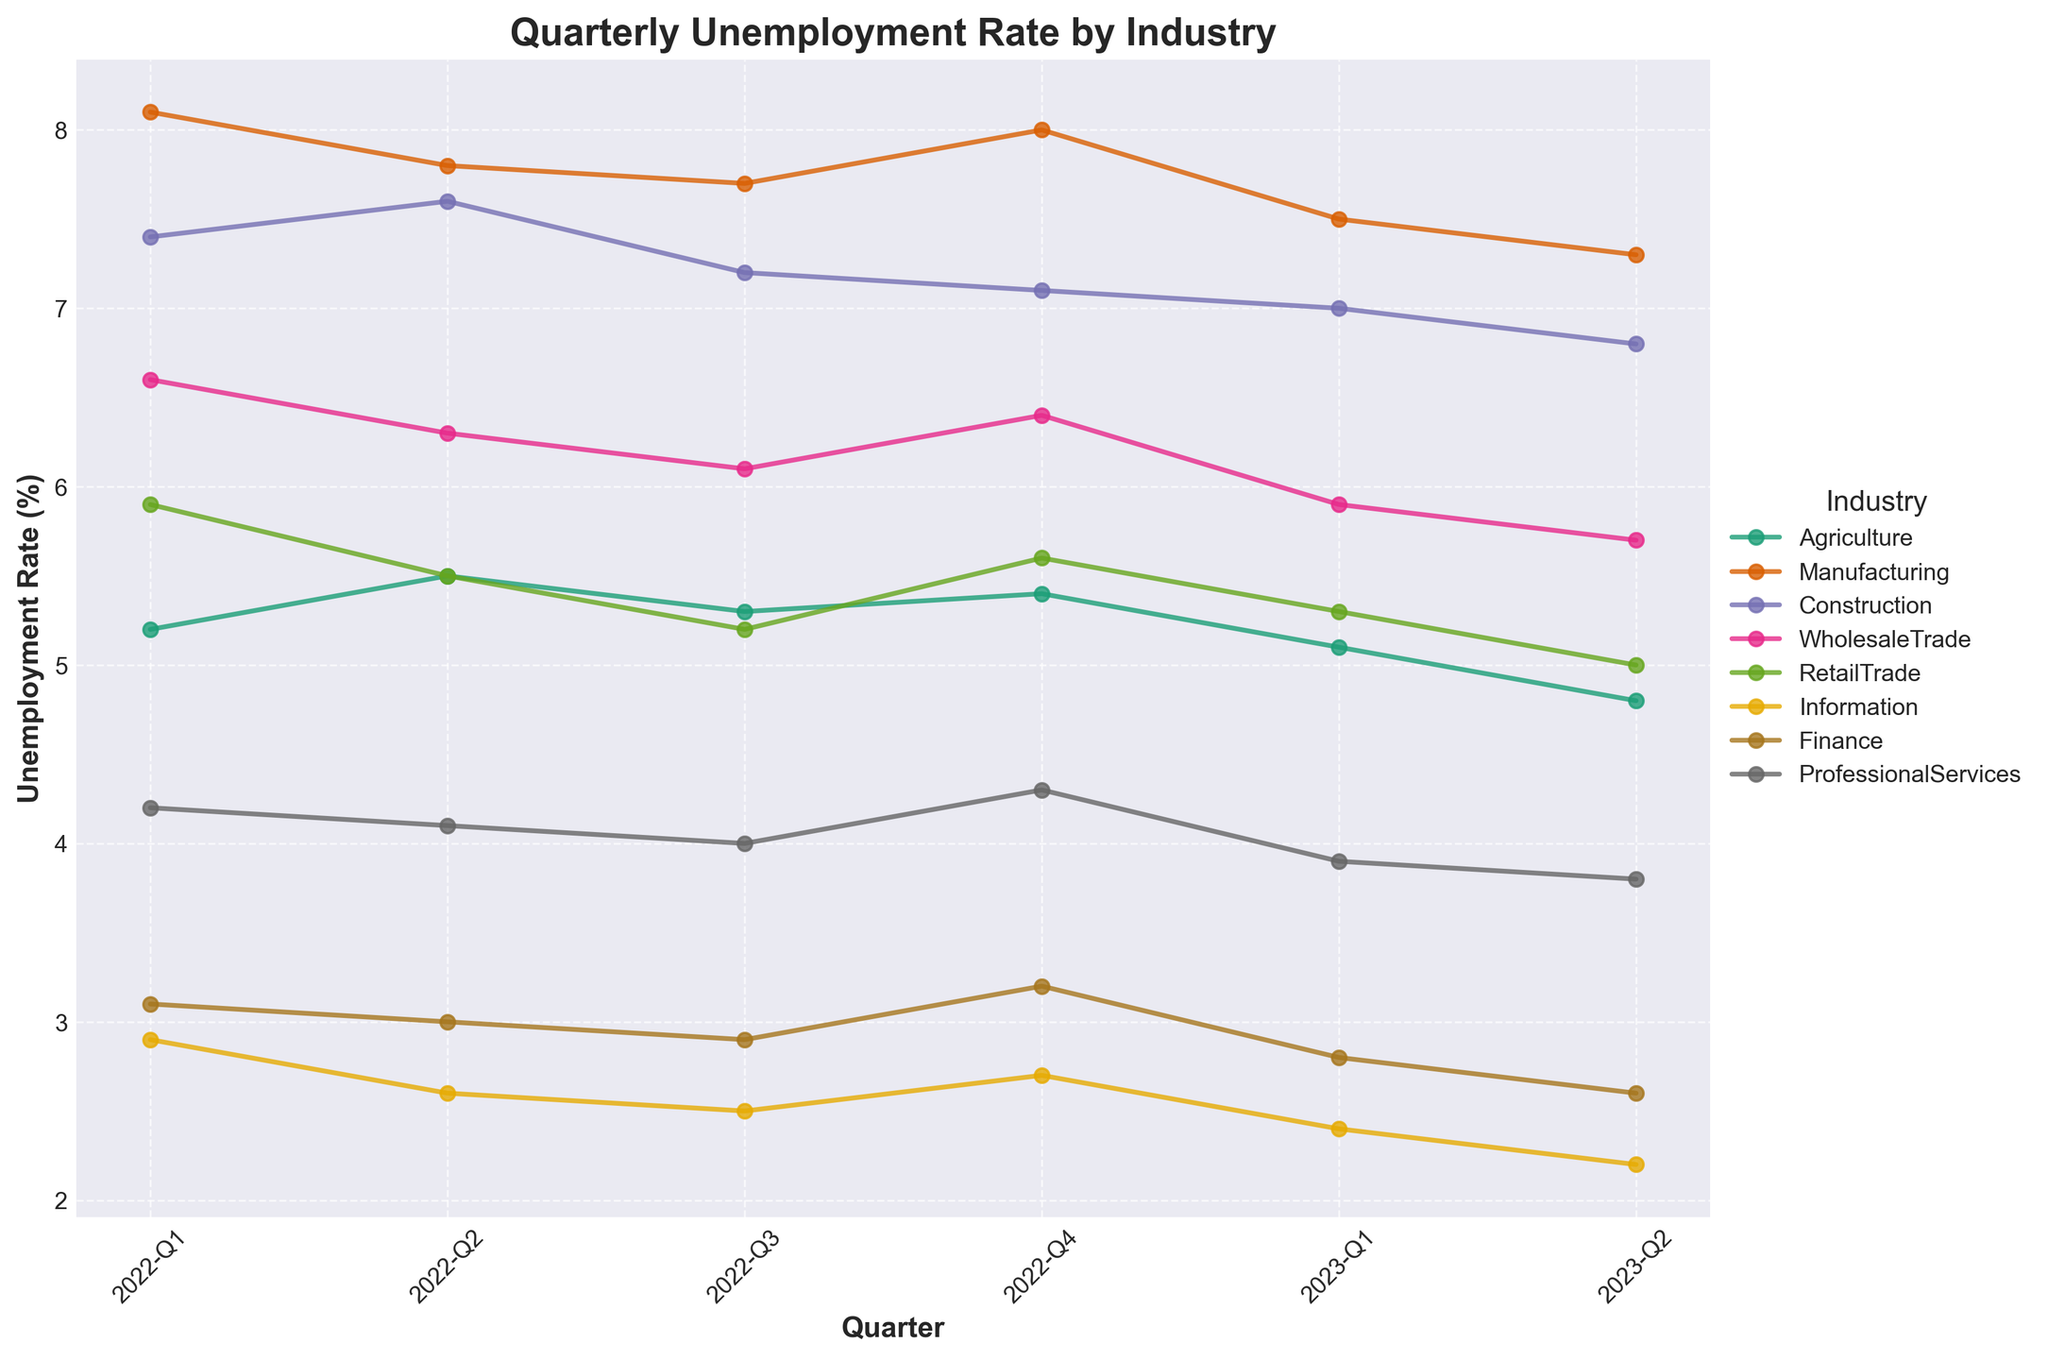What's the title of the figure? The title is displayed at the top center of the figure. It succinctly describes the content of the plot, highlighting that it's about quarterly unemployment rates across different industries.
Answer: Quarterly Unemployment Rate by Industry Which industry had the highest unemployment rate in 2022-Q4? Look at the 2022-Q4 points on the curve and identify which industry has the highest unemployment rate.
Answer: Manufacturing What is the trend of the unemployment rate in the Information industry from 2022-Q1 to 2023-Q2? Trace the curve for the Information industry from 2022-Q1 to 2023-Q2, noting the changes in the unemployment rate over each subsequent quarter. The trend shows a continuous decline.
Answer: Decreasing What is the average unemployment rate in the Retail Trade industry across all quarters displayed? Find the unemployment rates for the Retail Trade industry for each quarter, sum them up and then divide by the number of quarters (6).
Answer: (5.9 + 5.5 + 5.2 + 5.6 + 5.3 + 5.0) / 6 = 5.42% Between which two quarters did the Agriculture industry see the largest increase in unemployment rate? Compare the changes in the unemployment rate for the Agriculture industry between each pair of consecutive quarters. Identify which pair has the largest positive difference.
Answer: 2022-Q1 to 2022-Q2 Is there any industry that never reached an unemployment rate above 4% in the given time period? Check each industry’s curve to see if there are any points above 4%. The Information industry stays below 4% throughout the period.
Answer: Information Which industry experienced the most fluctuations in unemployment rate over the given quarters? Compare the ranges (maximum - minimum) of unemployment rates for each industry across the quarters. The industry with the largest range had the most fluctuations.
Answer: Manufacturing How did the unemployment rate in Professional Services change from 2023-Q1 to 2023-Q2? Compare the unemployment rates in the Professional Services industry between 2023-Q1 and 2023-Q2. The rate decreased from 3.9% to 3.8%.
Answer: Decreased Which quarter had the lowest average unemployment rate across all industries? Calculate the average unemployment rate for each quarter (sum the rates for all industries in that quarter and divide by the number of industries) and identify the quarter with the lowest average.
Answer: 2023-Q2 